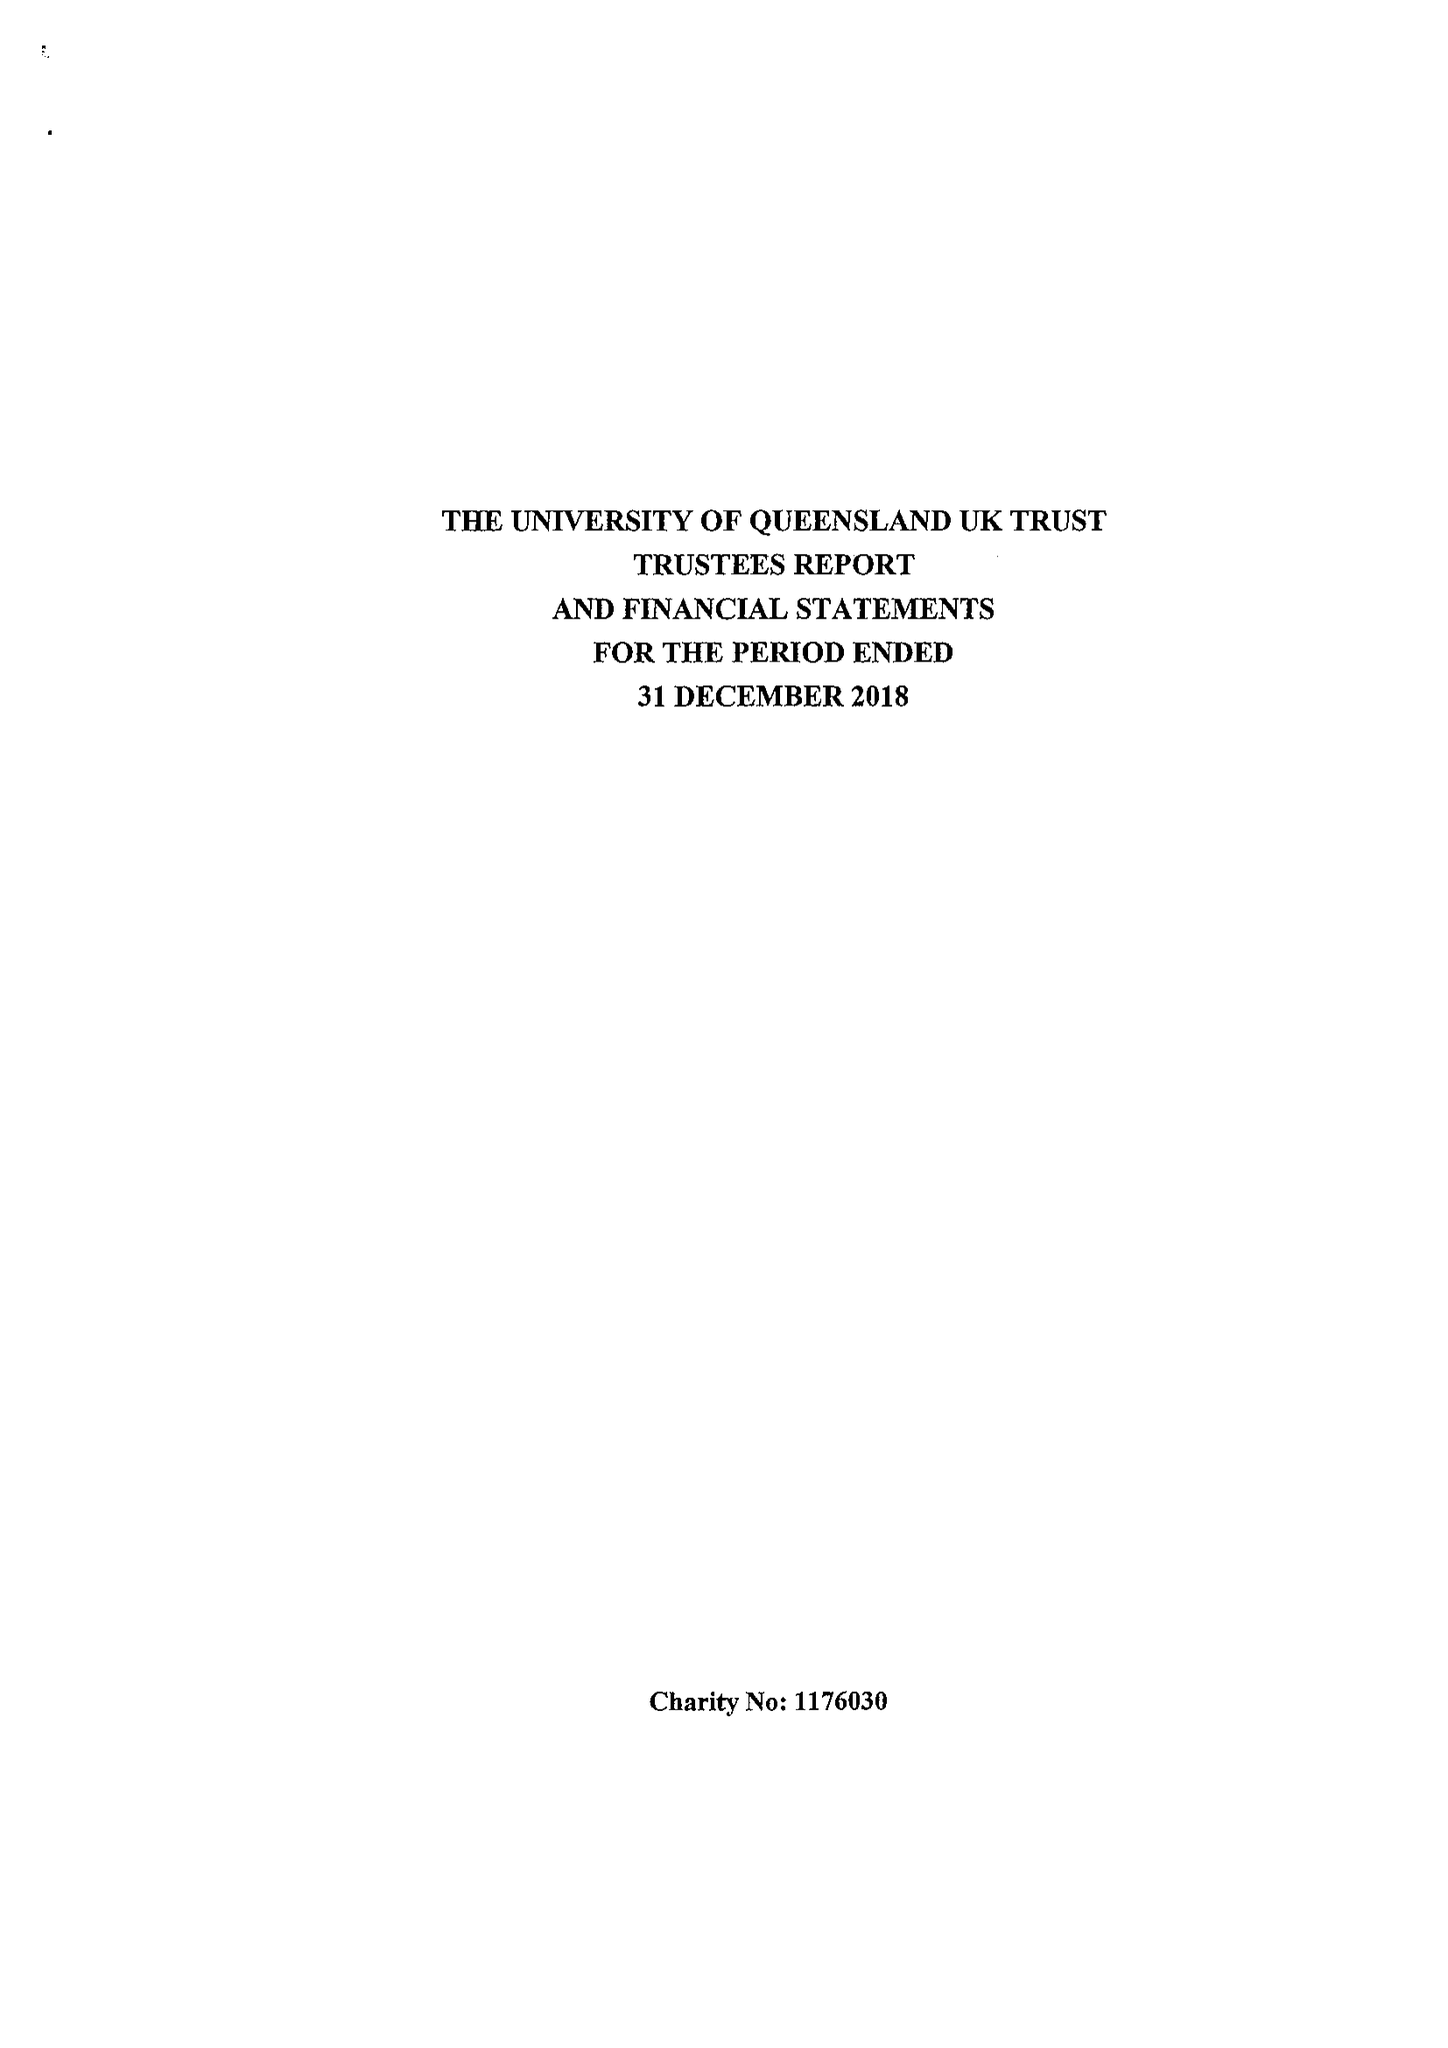What is the value for the address__street_line?
Answer the question using a single word or phrase. HOLLOW LANE 